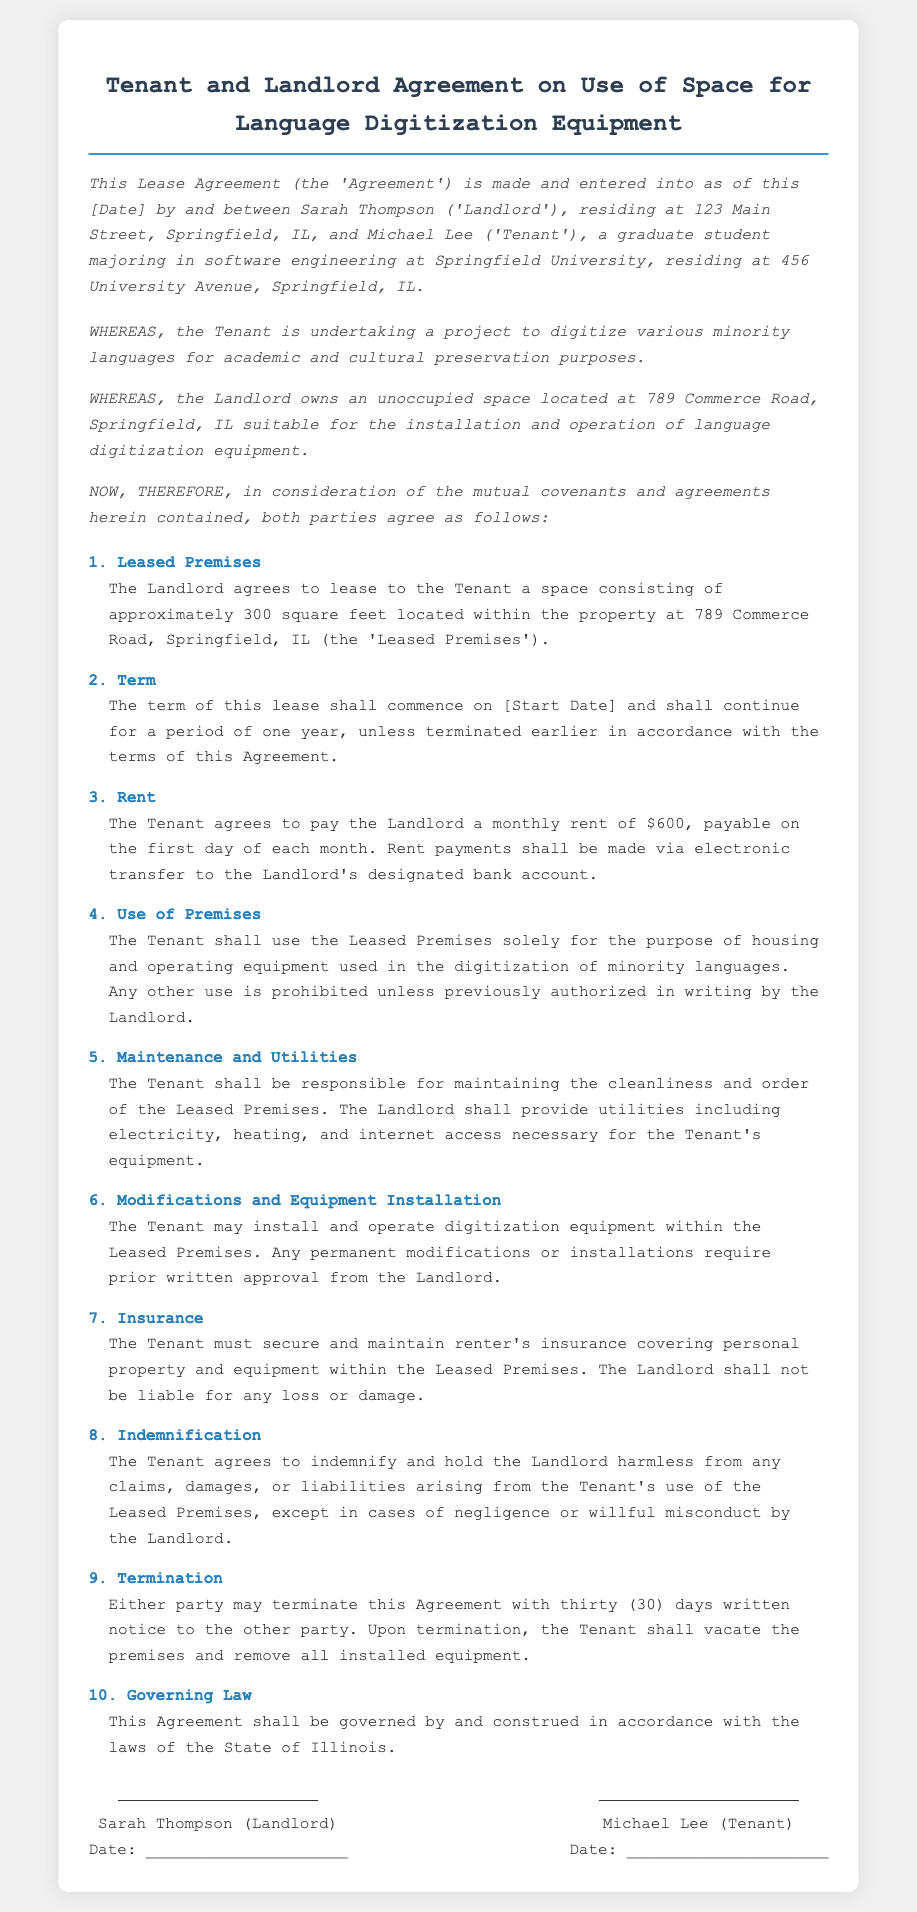What is the name of the Landlord? The document states that the Landlord is Sarah Thompson.
Answer: Sarah Thompson What is the address of the Leased Premises? The address of the Leased Premises is identified as 789 Commerce Road, Springfield, IL.
Answer: 789 Commerce Road, Springfield, IL What is the monthly rent amount? The document specifies that the monthly rent is $600.
Answer: $600 How long is the term of the lease? According to the agreement, the lease term is for a period of one year.
Answer: one year What is the Tenant required to maintain? The Tenant is responsible for maintaining the cleanliness and order of the Leased Premises.
Answer: cleanliness and order What type of insurance must the Tenant secure? The Tenant must secure renter's insurance covering personal property and equipment.
Answer: renter's insurance What constitutes a valid termination notice period? The agreement specifies that a termination notice requires thirty (30) days written notice.
Answer: thirty (30) days What is the purpose of using the Leased Premises? The purpose of the use of the Leased Premises is for housing and operating digitization equipment.
Answer: housing and operating digitization equipment Which law governs this Agreement? The document states that this Agreement shall be governed by the laws of the State of Illinois.
Answer: laws of the State of Illinois 